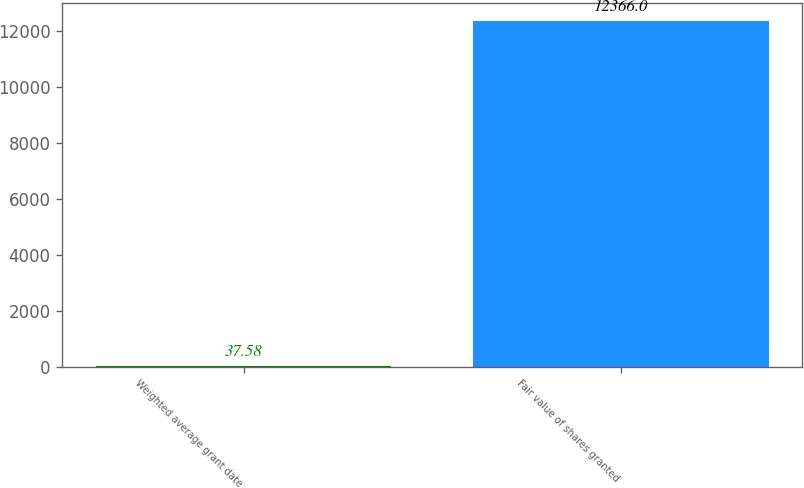<chart> <loc_0><loc_0><loc_500><loc_500><bar_chart><fcel>Weighted average grant date<fcel>Fair value of shares granted<nl><fcel>37.58<fcel>12366<nl></chart> 